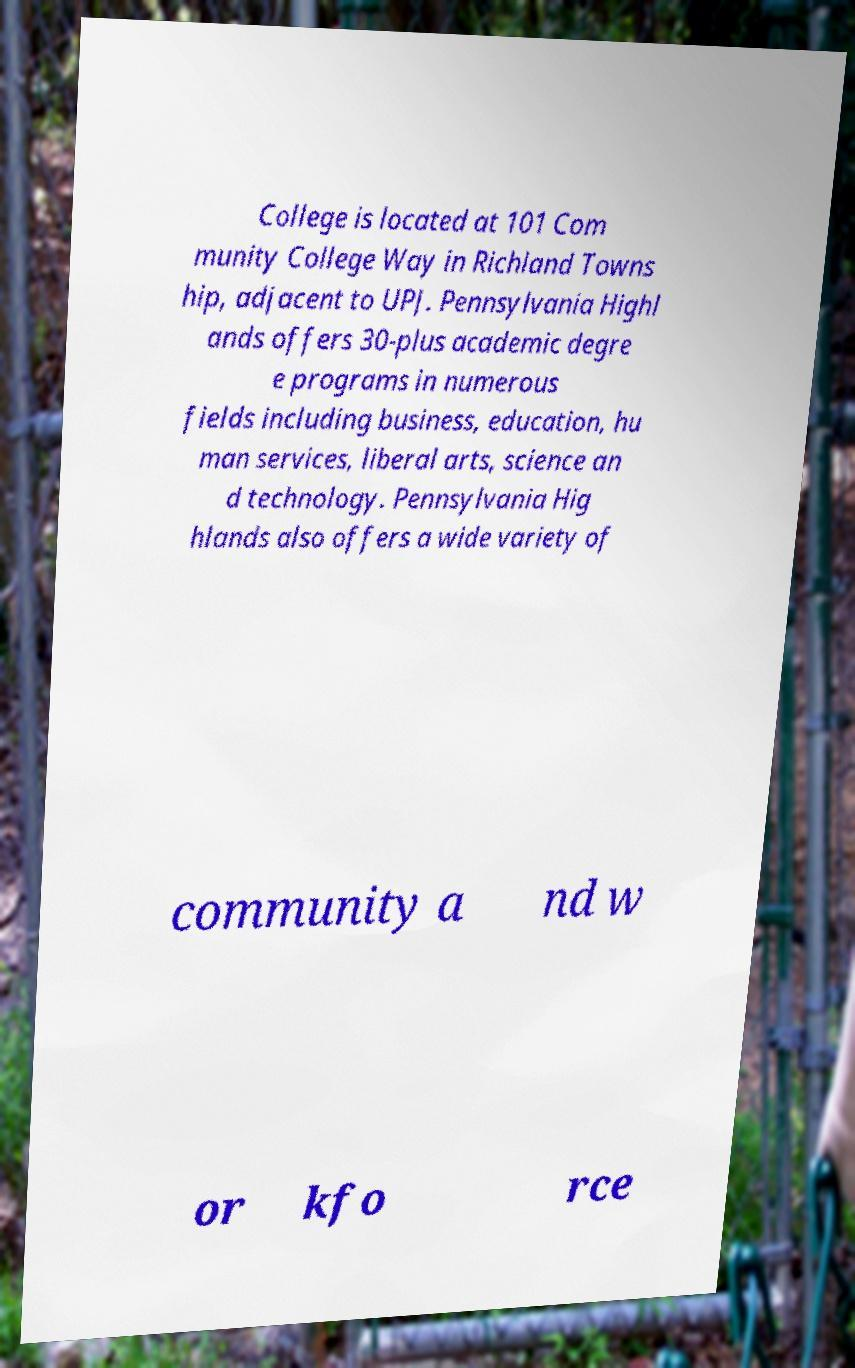Please identify and transcribe the text found in this image. College is located at 101 Com munity College Way in Richland Towns hip, adjacent to UPJ. Pennsylvania Highl ands offers 30-plus academic degre e programs in numerous fields including business, education, hu man services, liberal arts, science an d technology. Pennsylvania Hig hlands also offers a wide variety of community a nd w or kfo rce 